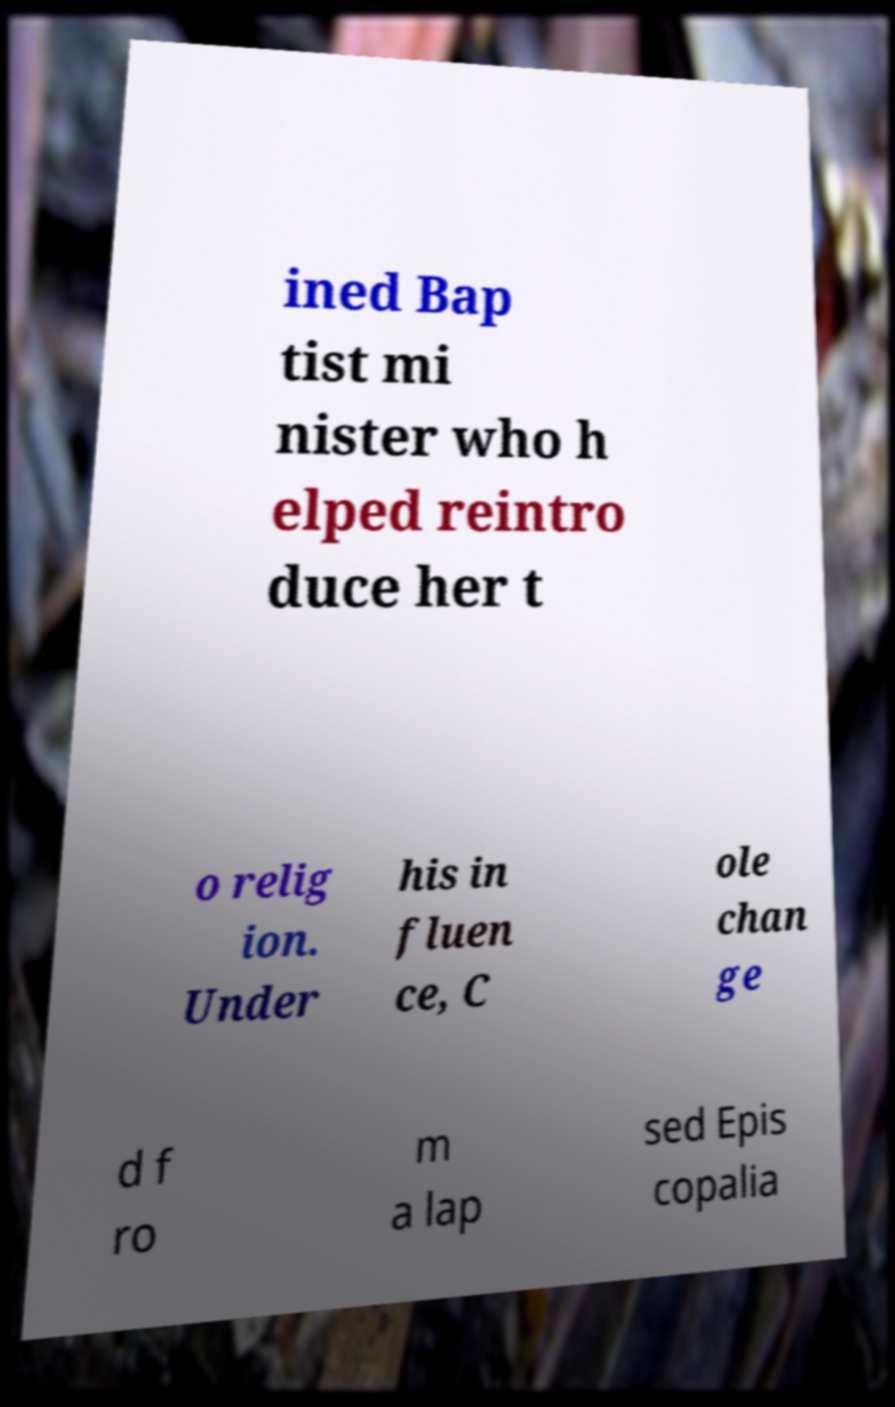Please identify and transcribe the text found in this image. ined Bap tist mi nister who h elped reintro duce her t o relig ion. Under his in fluen ce, C ole chan ge d f ro m a lap sed Epis copalia 